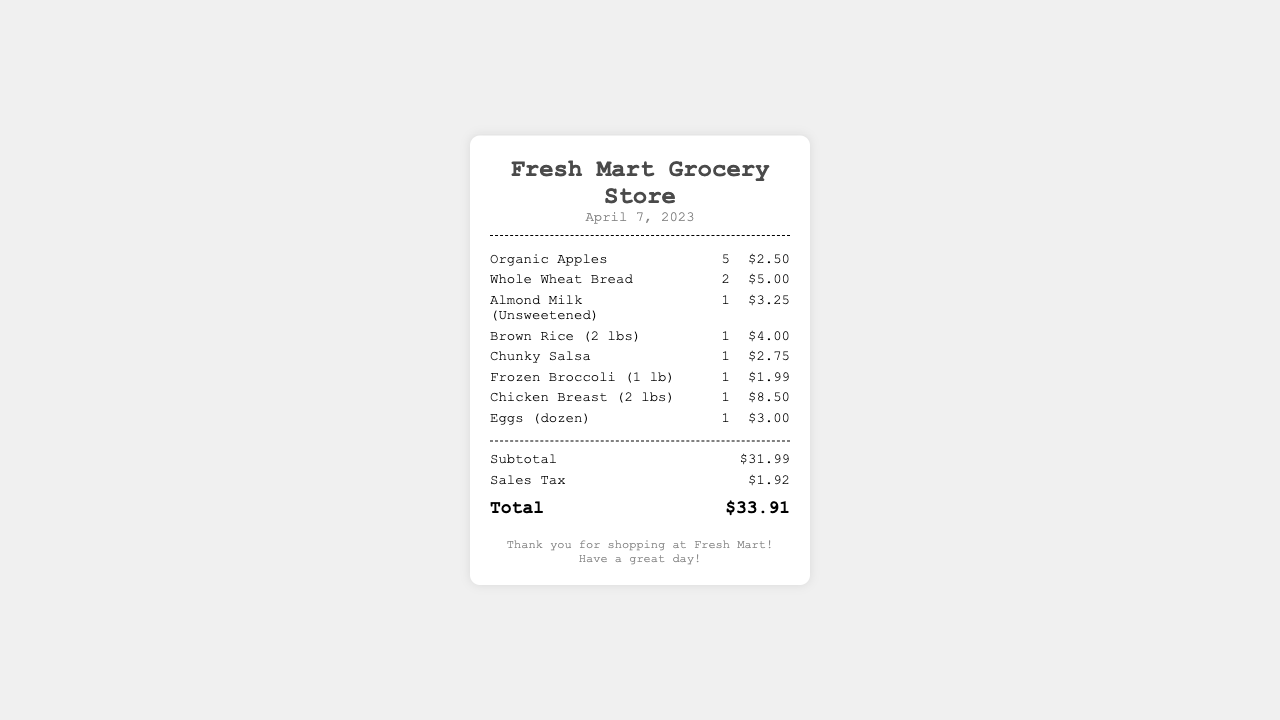What is the date of the receipt? The date of the receipt is displayed under the store name, showing when the shopping took place.
Answer: April 7, 2023 How many items are listed in the receipt? The number of items is determined by counting the individual items listed under the items section.
Answer: 8 What is the price of Almond Milk? The price of Almond Milk is shown next to the item in the price column.
Answer: $3.25 What is the subtotal of the groceries? The subtotal is presented before any sales tax is applied, indicating the total before tax.
Answer: $31.99 What is the grand total amount? The grand total is provided at the end of the receipt, representing the total cost after including sales tax.
Answer: $33.91 Which item has the highest price? The price of each item can be compared to identify the item that costs the most.
Answer: Chicken Breast (2 lbs) How many Whole Wheat Breads were purchased? The quantity is found next to the item name, showing how many were selected.
Answer: 2 What is the sales tax amount? The sales tax is indicated on the receipt, showing the amount charged for tax.
Answer: $1.92 What type of store issued this receipt? The store name at the top of the receipt indicates the type of store.
Answer: Grocery Store 